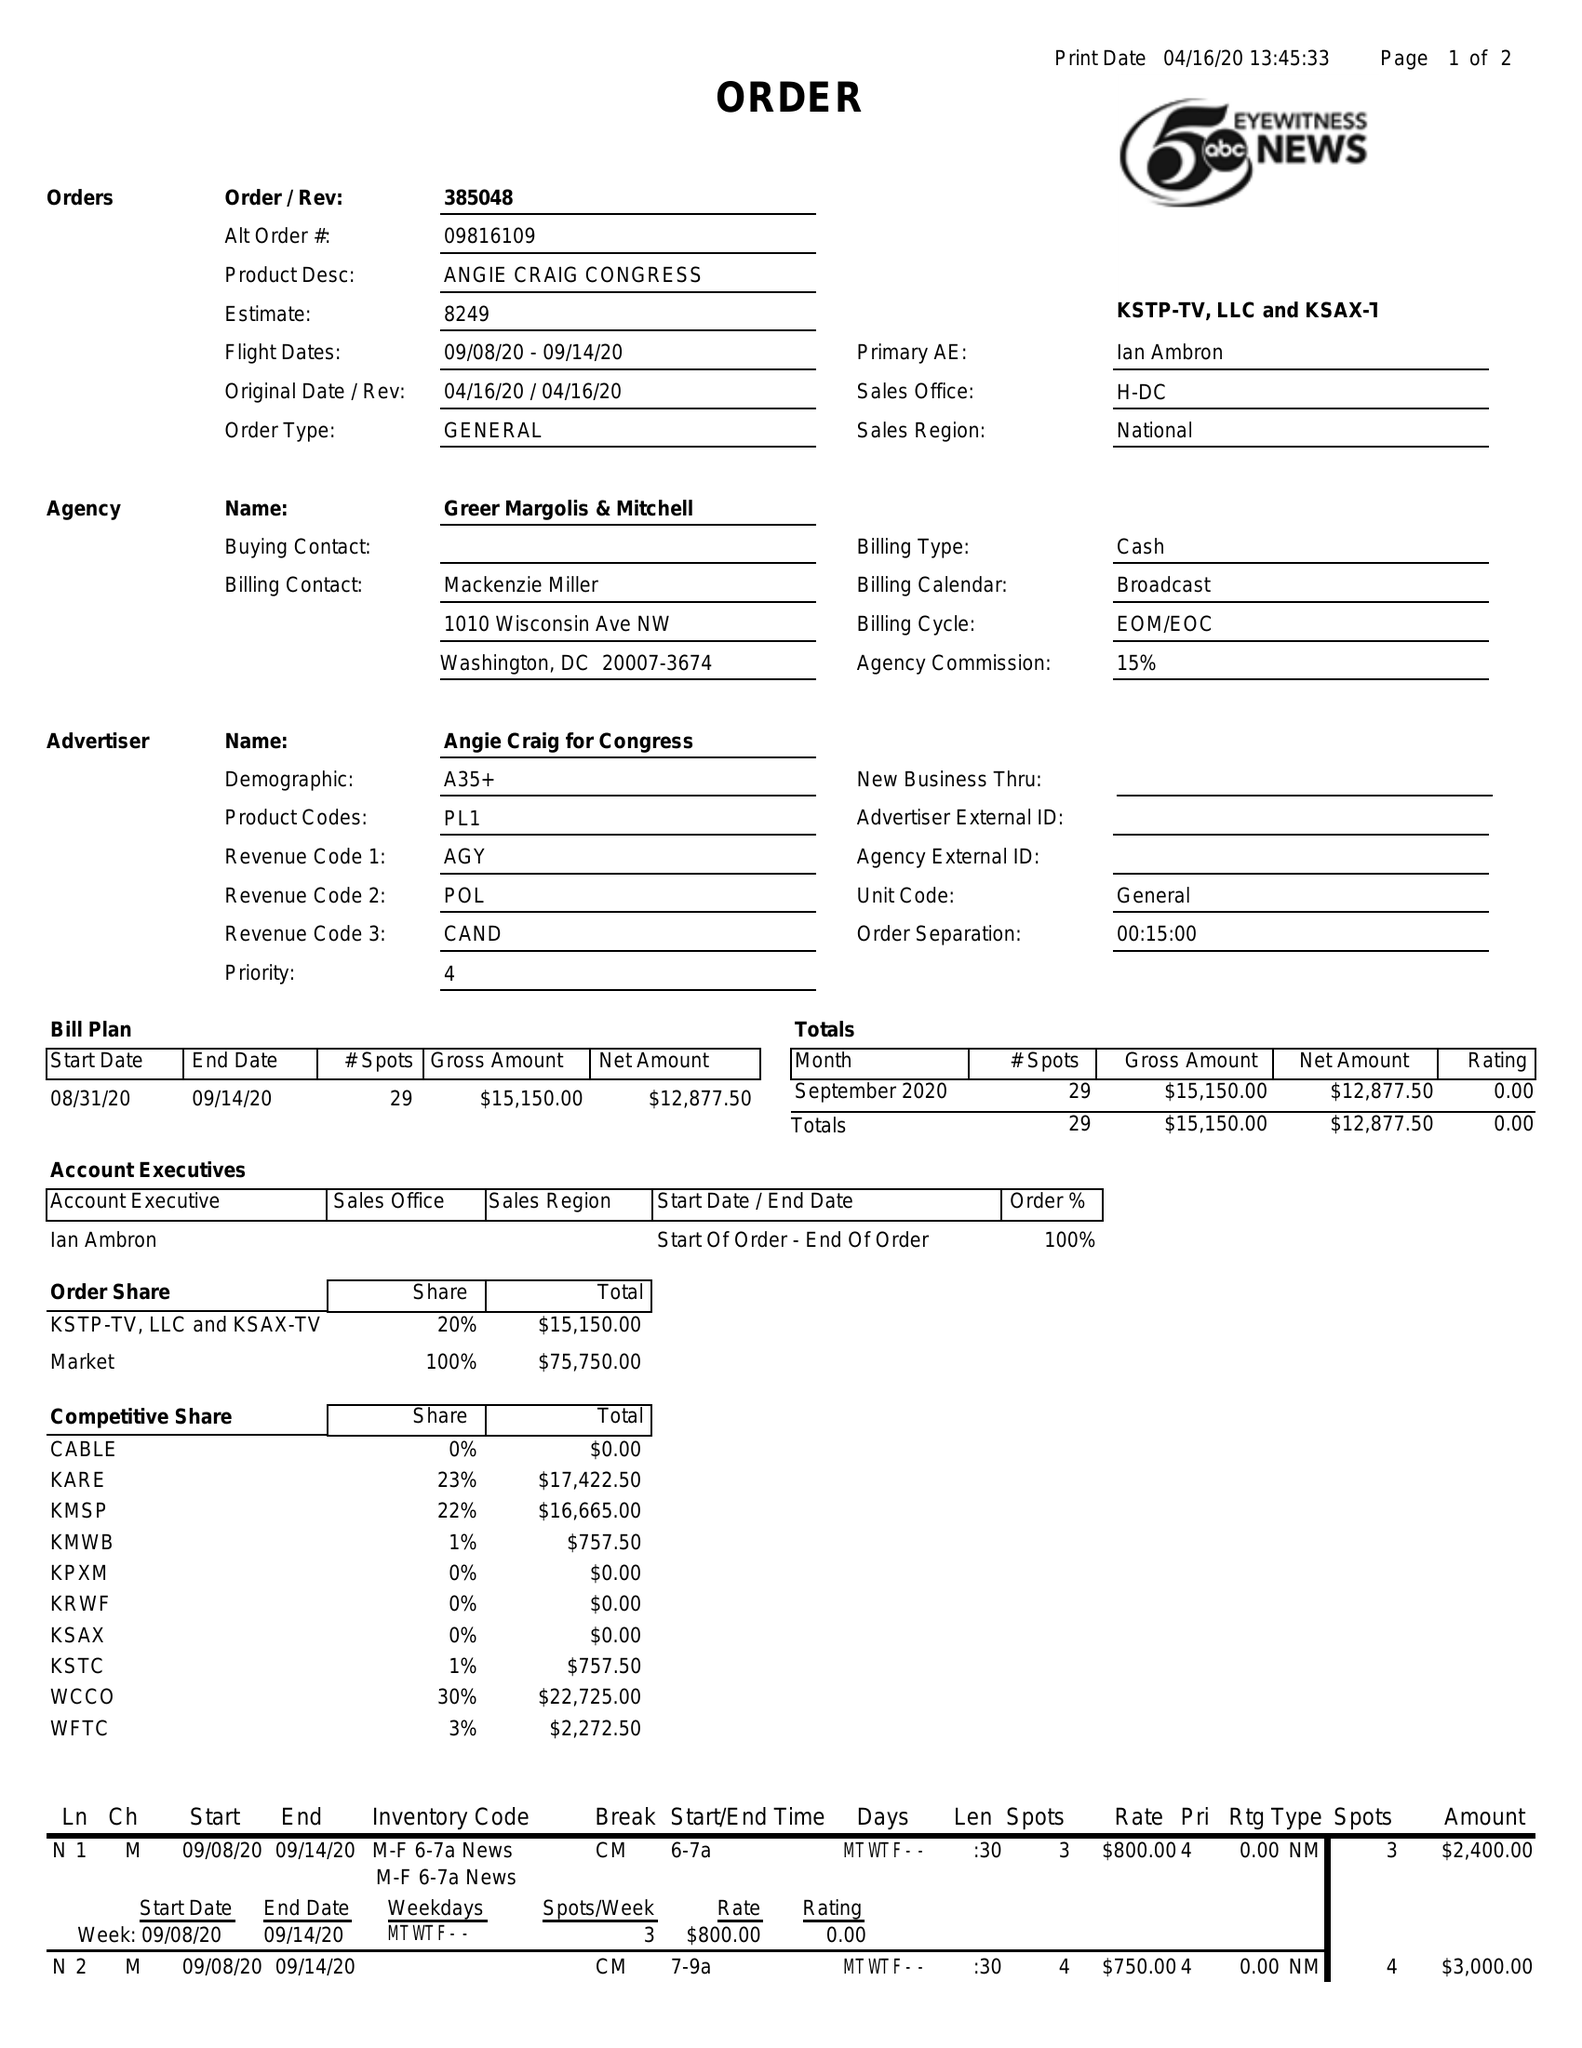What is the value for the flight_to?
Answer the question using a single word or phrase. 09/14/20 